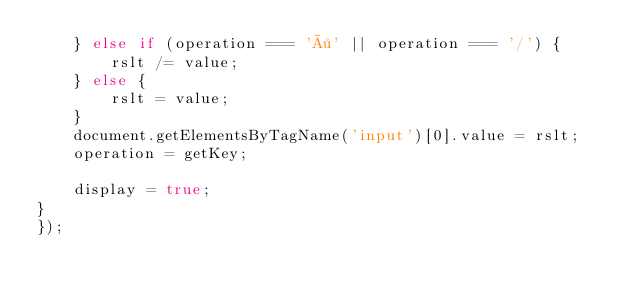Convert code to text. <code><loc_0><loc_0><loc_500><loc_500><_JavaScript_>    } else if (operation === '÷' || operation === '/') {
        rslt /= value;
    } else {
        rslt = value;
    }
    document.getElementsByTagName('input')[0].value = rslt;
    operation = getKey;

    display = true;
}
});
</code> 